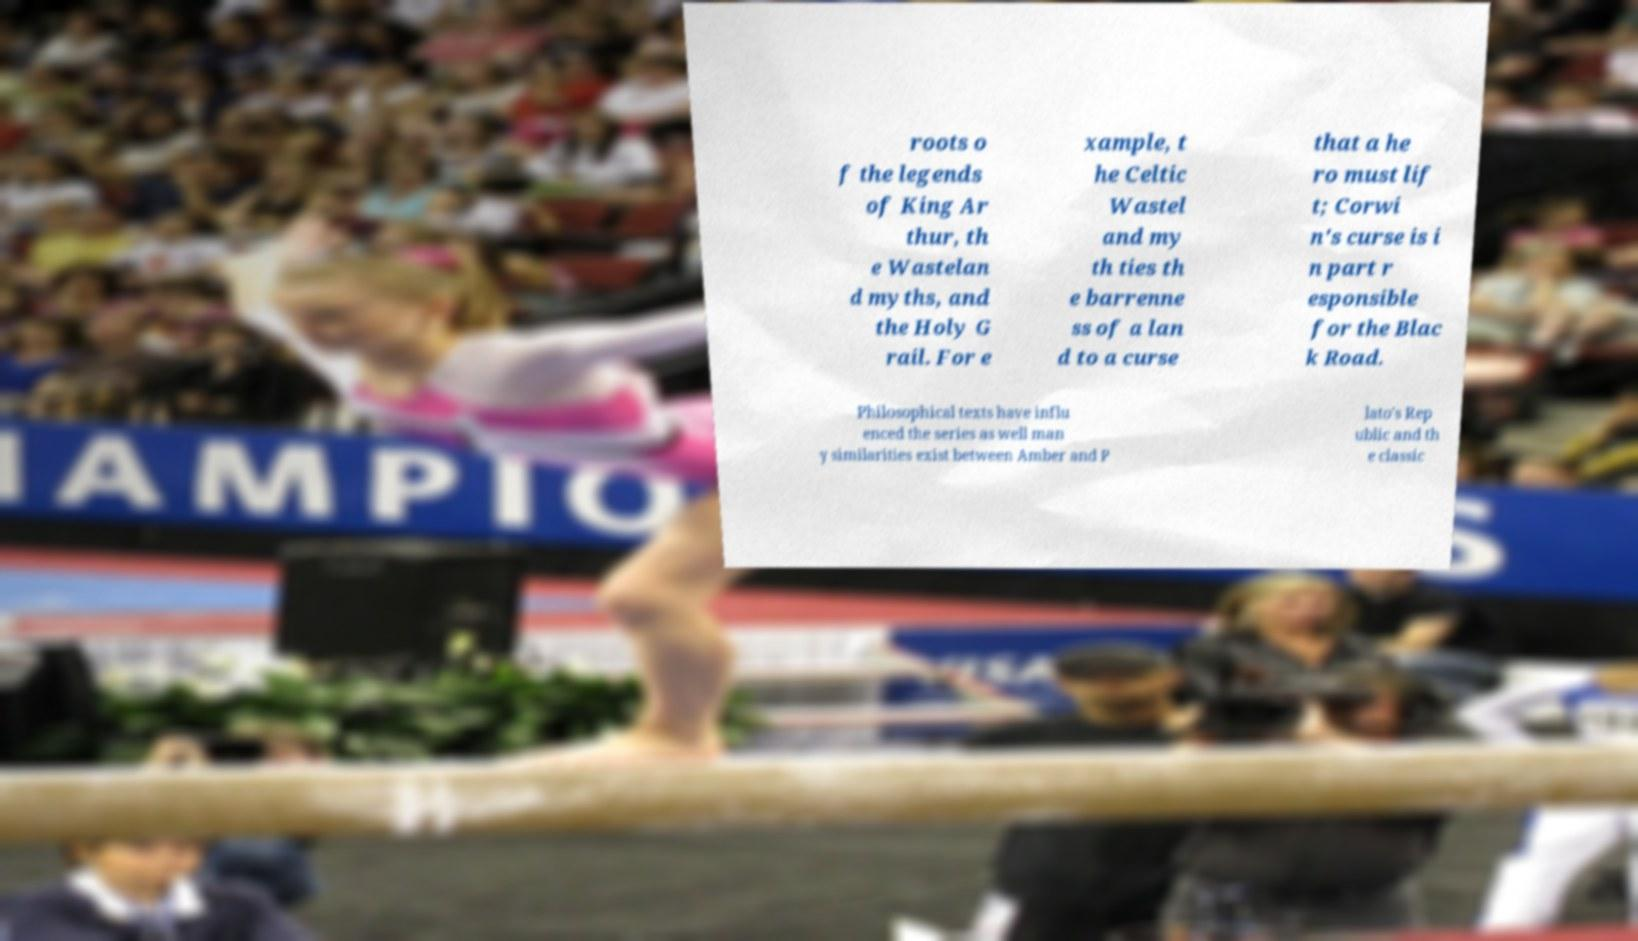Can you read and provide the text displayed in the image?This photo seems to have some interesting text. Can you extract and type it out for me? roots o f the legends of King Ar thur, th e Wastelan d myths, and the Holy G rail. For e xample, t he Celtic Wastel and my th ties th e barrenne ss of a lan d to a curse that a he ro must lif t; Corwi n's curse is i n part r esponsible for the Blac k Road. Philosophical texts have influ enced the series as well man y similarities exist between Amber and P lato's Rep ublic and th e classic 